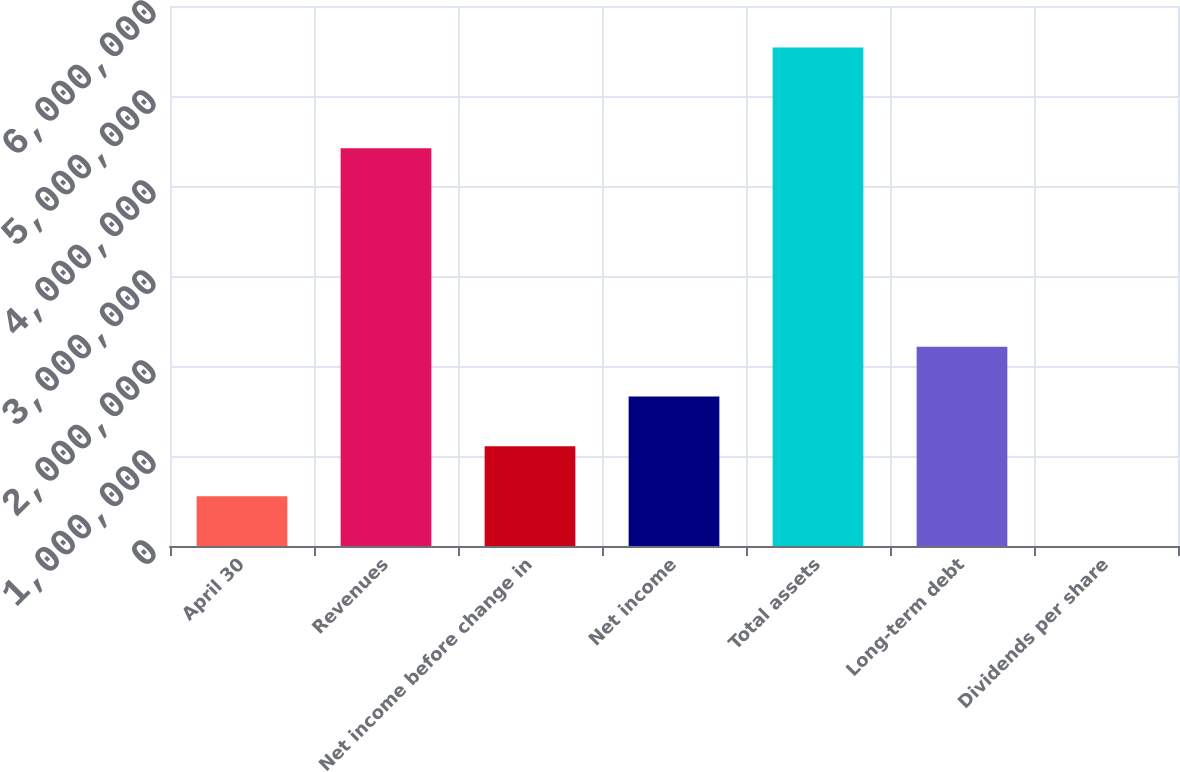Convert chart. <chart><loc_0><loc_0><loc_500><loc_500><bar_chart><fcel>April 30<fcel>Revenues<fcel>Net income before change in<fcel>Net income<fcel>Total assets<fcel>Long-term debt<fcel>Dividends per share<nl><fcel>553806<fcel>4.42002e+06<fcel>1.10761e+06<fcel>1.66142e+06<fcel>5.53806e+06<fcel>2.21522e+06<fcel>0.43<nl></chart> 